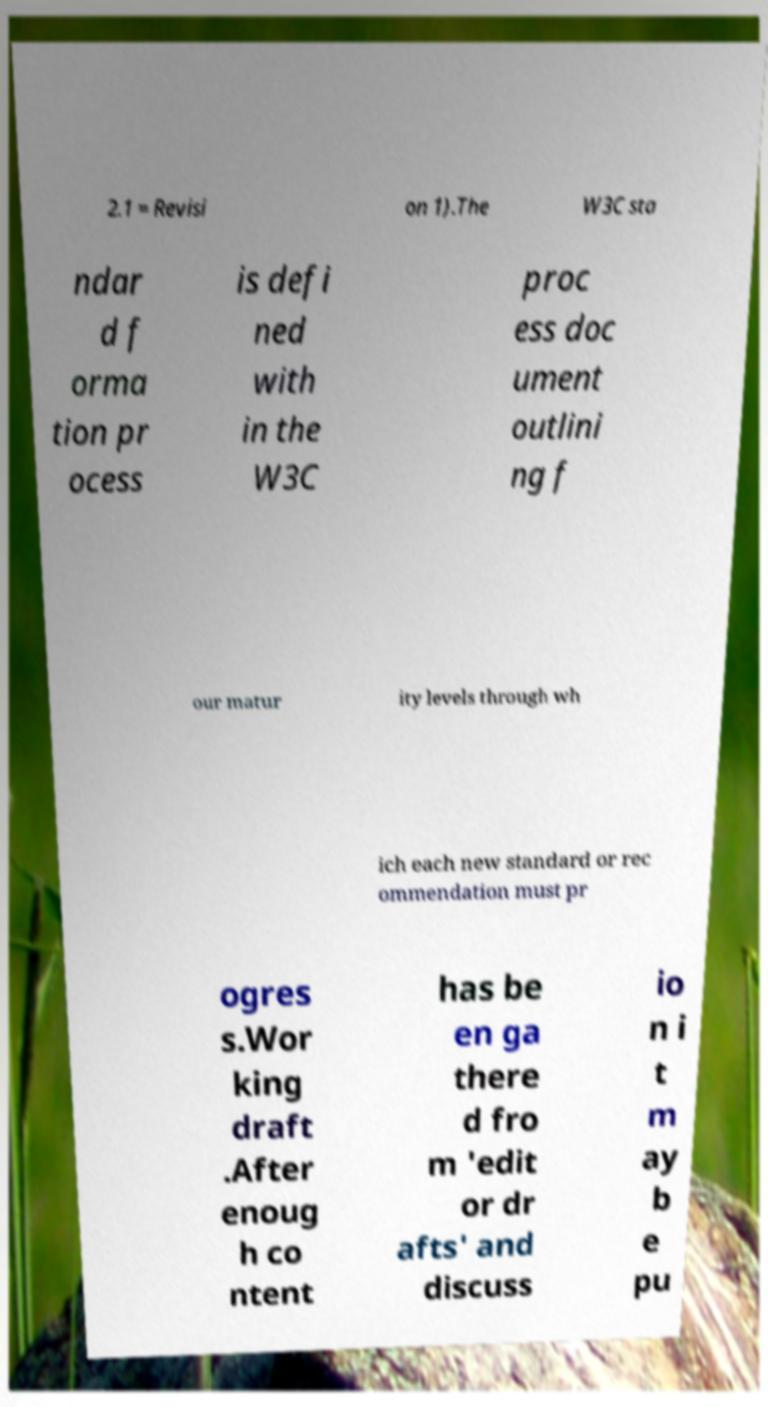For documentation purposes, I need the text within this image transcribed. Could you provide that? 2.1 = Revisi on 1).The W3C sta ndar d f orma tion pr ocess is defi ned with in the W3C proc ess doc ument outlini ng f our matur ity levels through wh ich each new standard or rec ommendation must pr ogres s.Wor king draft .After enoug h co ntent has be en ga there d fro m 'edit or dr afts' and discuss io n i t m ay b e pu 